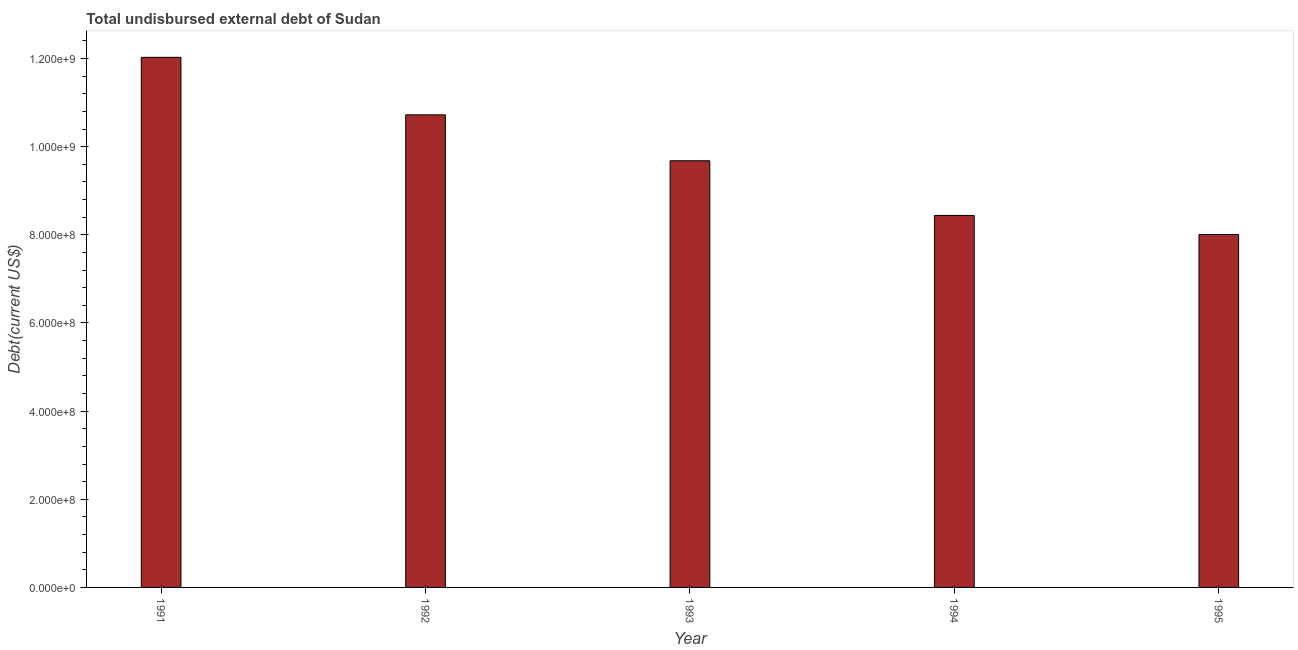What is the title of the graph?
Offer a very short reply. Total undisbursed external debt of Sudan. What is the label or title of the Y-axis?
Provide a succinct answer. Debt(current US$). What is the total debt in 1991?
Offer a very short reply. 1.20e+09. Across all years, what is the maximum total debt?
Offer a terse response. 1.20e+09. Across all years, what is the minimum total debt?
Offer a terse response. 8.01e+08. In which year was the total debt minimum?
Provide a short and direct response. 1995. What is the sum of the total debt?
Offer a terse response. 4.89e+09. What is the difference between the total debt in 1993 and 1994?
Your response must be concise. 1.24e+08. What is the average total debt per year?
Your answer should be compact. 9.78e+08. What is the median total debt?
Make the answer very short. 9.68e+08. In how many years, is the total debt greater than 1000000000 US$?
Ensure brevity in your answer.  2. What is the ratio of the total debt in 1991 to that in 1992?
Give a very brief answer. 1.12. What is the difference between the highest and the second highest total debt?
Offer a very short reply. 1.30e+08. Is the sum of the total debt in 1994 and 1995 greater than the maximum total debt across all years?
Offer a very short reply. Yes. What is the difference between the highest and the lowest total debt?
Offer a terse response. 4.02e+08. How many bars are there?
Provide a succinct answer. 5. Are all the bars in the graph horizontal?
Provide a succinct answer. No. How many years are there in the graph?
Provide a short and direct response. 5. What is the difference between two consecutive major ticks on the Y-axis?
Your answer should be very brief. 2.00e+08. What is the Debt(current US$) of 1991?
Ensure brevity in your answer.  1.20e+09. What is the Debt(current US$) of 1992?
Offer a very short reply. 1.07e+09. What is the Debt(current US$) of 1993?
Provide a succinct answer. 9.68e+08. What is the Debt(current US$) in 1994?
Give a very brief answer. 8.44e+08. What is the Debt(current US$) of 1995?
Your answer should be compact. 8.01e+08. What is the difference between the Debt(current US$) in 1991 and 1992?
Give a very brief answer. 1.30e+08. What is the difference between the Debt(current US$) in 1991 and 1993?
Your answer should be very brief. 2.35e+08. What is the difference between the Debt(current US$) in 1991 and 1994?
Your answer should be compact. 3.59e+08. What is the difference between the Debt(current US$) in 1991 and 1995?
Your answer should be compact. 4.02e+08. What is the difference between the Debt(current US$) in 1992 and 1993?
Give a very brief answer. 1.04e+08. What is the difference between the Debt(current US$) in 1992 and 1994?
Keep it short and to the point. 2.28e+08. What is the difference between the Debt(current US$) in 1992 and 1995?
Give a very brief answer. 2.72e+08. What is the difference between the Debt(current US$) in 1993 and 1994?
Provide a short and direct response. 1.24e+08. What is the difference between the Debt(current US$) in 1993 and 1995?
Ensure brevity in your answer.  1.67e+08. What is the difference between the Debt(current US$) in 1994 and 1995?
Provide a succinct answer. 4.33e+07. What is the ratio of the Debt(current US$) in 1991 to that in 1992?
Provide a short and direct response. 1.12. What is the ratio of the Debt(current US$) in 1991 to that in 1993?
Provide a short and direct response. 1.24. What is the ratio of the Debt(current US$) in 1991 to that in 1994?
Provide a succinct answer. 1.43. What is the ratio of the Debt(current US$) in 1991 to that in 1995?
Provide a short and direct response. 1.5. What is the ratio of the Debt(current US$) in 1992 to that in 1993?
Keep it short and to the point. 1.11. What is the ratio of the Debt(current US$) in 1992 to that in 1994?
Your answer should be compact. 1.27. What is the ratio of the Debt(current US$) in 1992 to that in 1995?
Keep it short and to the point. 1.34. What is the ratio of the Debt(current US$) in 1993 to that in 1994?
Offer a very short reply. 1.15. What is the ratio of the Debt(current US$) in 1993 to that in 1995?
Give a very brief answer. 1.21. What is the ratio of the Debt(current US$) in 1994 to that in 1995?
Provide a short and direct response. 1.05. 